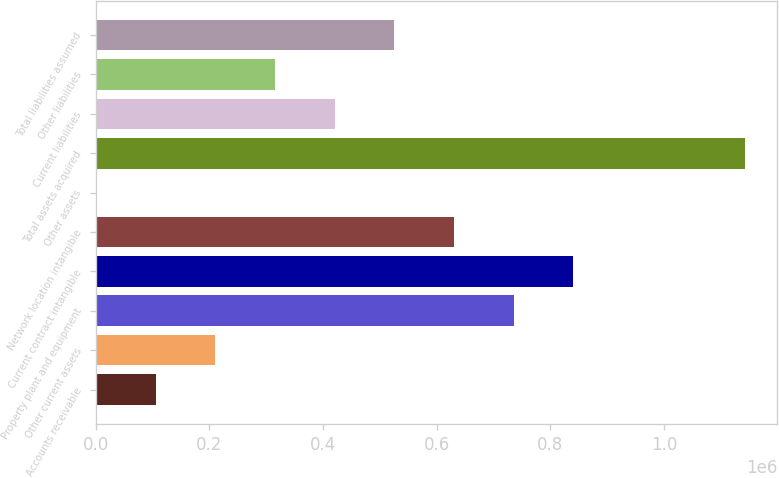Convert chart to OTSL. <chart><loc_0><loc_0><loc_500><loc_500><bar_chart><fcel>Accounts receivable<fcel>Other current assets<fcel>Property plant and equipment<fcel>Current contract intangible<fcel>Network location intangible<fcel>Other assets<fcel>Total assets acquired<fcel>Current liabilities<fcel>Other liabilities<fcel>Total liabilities assumed<nl><fcel>105714<fcel>210703<fcel>735644<fcel>840632<fcel>630656<fcel>726<fcel>1.14214e+06<fcel>420679<fcel>315691<fcel>525668<nl></chart> 